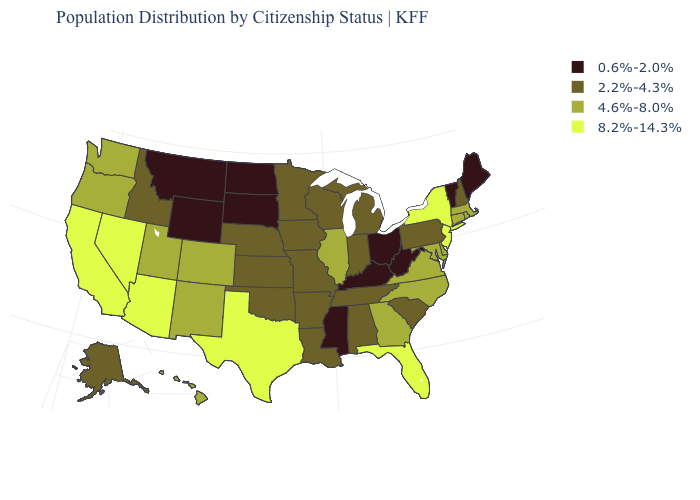What is the value of South Carolina?
Concise answer only. 2.2%-4.3%. What is the value of Colorado?
Concise answer only. 4.6%-8.0%. Name the states that have a value in the range 2.2%-4.3%?
Be succinct. Alabama, Alaska, Arkansas, Idaho, Indiana, Iowa, Kansas, Louisiana, Michigan, Minnesota, Missouri, Nebraska, New Hampshire, Oklahoma, Pennsylvania, South Carolina, Tennessee, Wisconsin. What is the value of Idaho?
Quick response, please. 2.2%-4.3%. Among the states that border Connecticut , does Massachusetts have the lowest value?
Give a very brief answer. Yes. Does California have the highest value in the USA?
Answer briefly. Yes. How many symbols are there in the legend?
Concise answer only. 4. Which states have the lowest value in the MidWest?
Answer briefly. North Dakota, Ohio, South Dakota. Does Maryland have a lower value than Florida?
Give a very brief answer. Yes. Among the states that border Wisconsin , does Illinois have the lowest value?
Give a very brief answer. No. What is the value of North Carolina?
Short answer required. 4.6%-8.0%. Does Hawaii have the lowest value in the West?
Give a very brief answer. No. What is the value of Tennessee?
Write a very short answer. 2.2%-4.3%. What is the highest value in the USA?
Give a very brief answer. 8.2%-14.3%. Among the states that border Utah , which have the highest value?
Short answer required. Arizona, Nevada. 